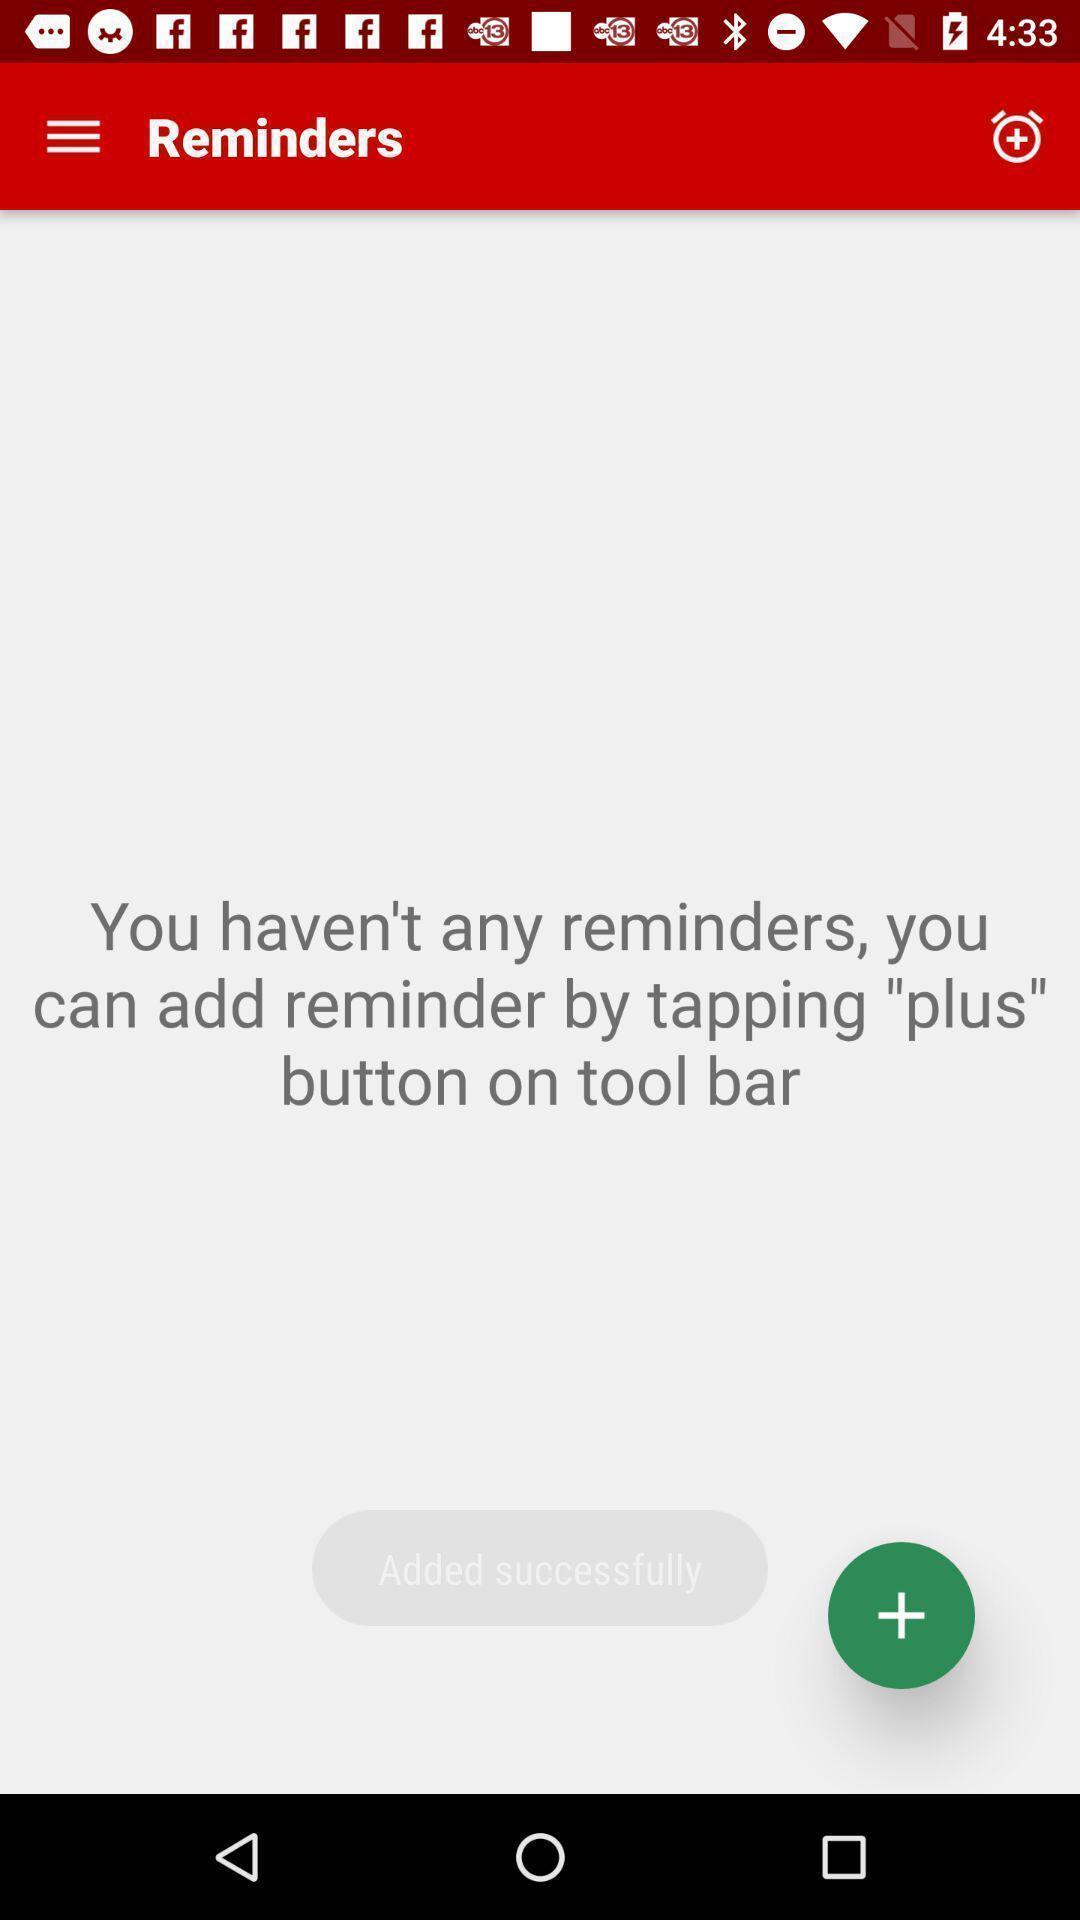Describe the visual elements of this screenshot. Screen showing you have n't any reminders with add option. 